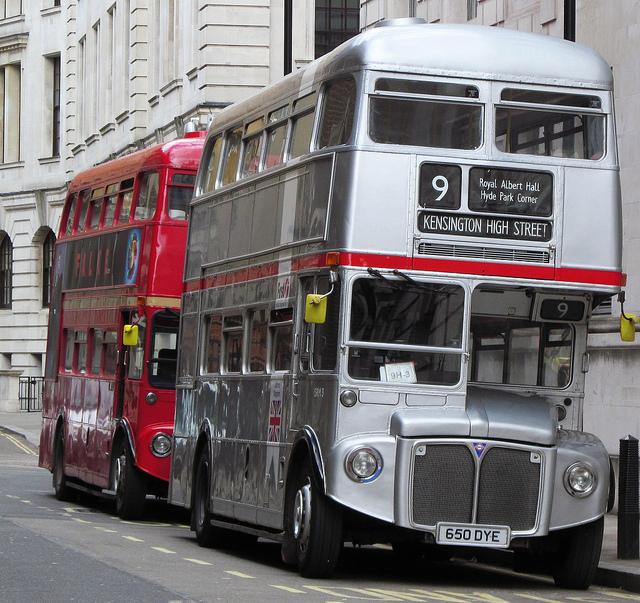Where are the rest of his license plate?
Concise answer only. Back. What color is the front bus?
Concise answer only. Silver. What country is this?
Quick response, please. England. How many buses are shown?
Concise answer only. 2. How many buses are there?
Short answer required. 2. How many buses are shown in this picture?
Keep it brief. 2. What color is the bus?
Short answer required. Silver. Is there a bus in each lane?
Short answer required. No. 